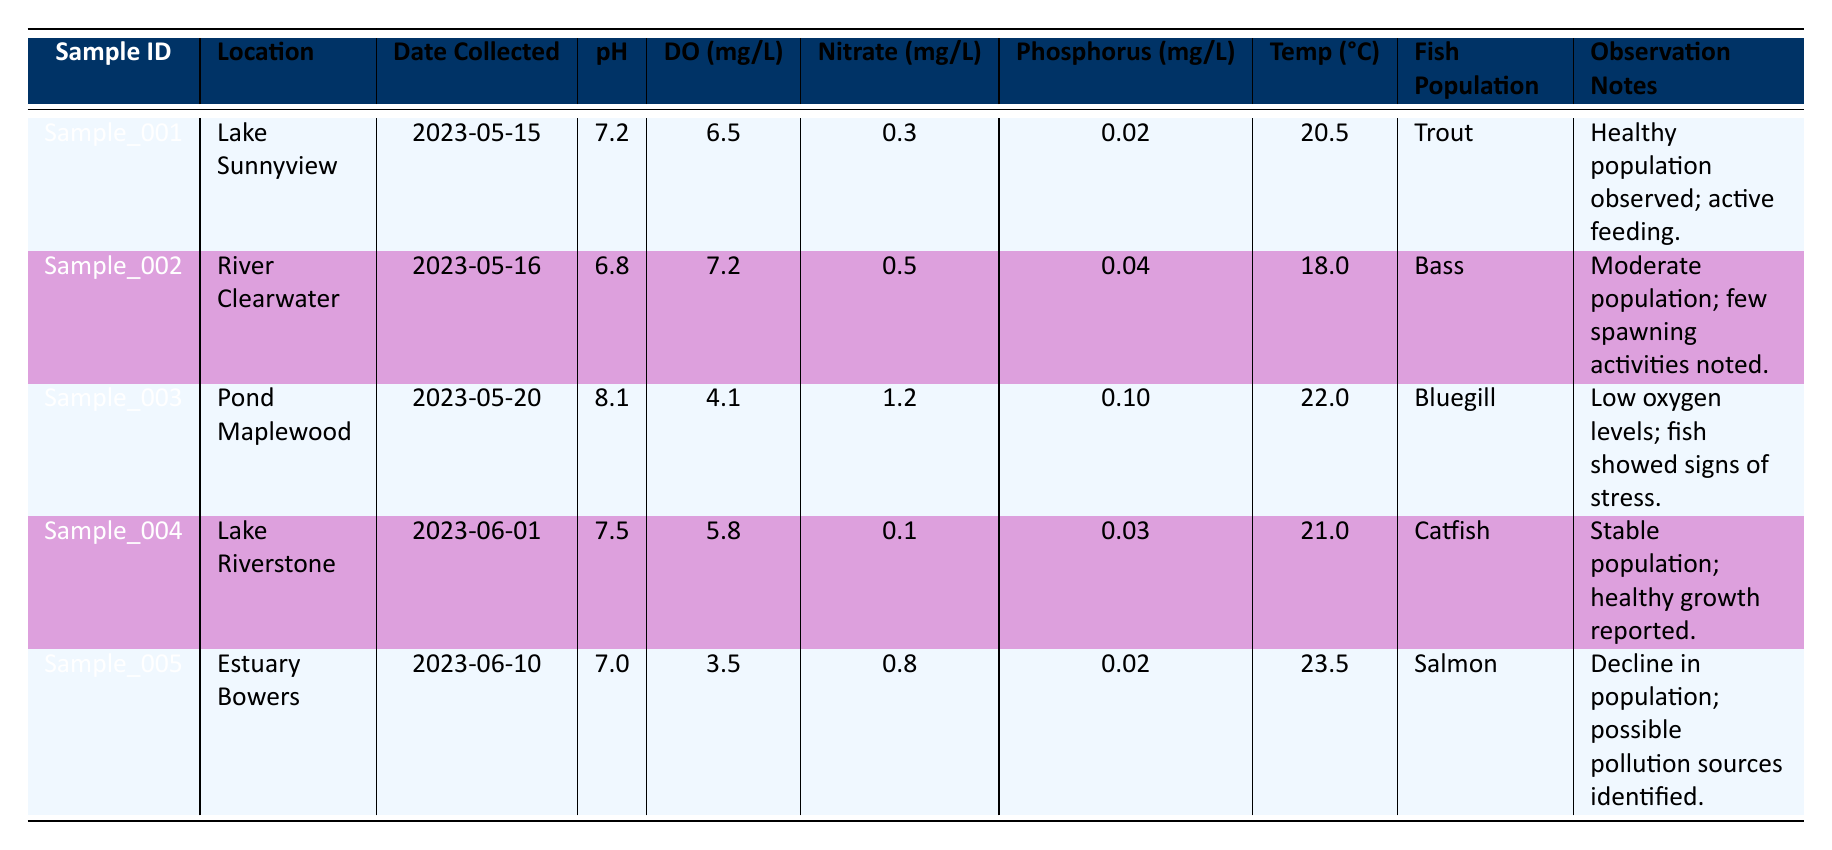What is the pH level of the water at Lake Sunnyview? The table shows a sample taken from Lake Sunnyview, which includes a pH value listed in the pH column. According to the row for Sample_001, the pH level is 7.2.
Answer: 7.2 Which fish population was observed in the River Clearwater? To determine the fish population in River Clearwater, look at the entry for Sample_002 where this location is mentioned. The fish population for this sample is recorded as Bass.
Answer: Bass What is the average temperature of the water samples collected? The temperatures from the table are: 20.5, 18.0, 22.0, 21.0, and 23.5 degrees Celsius. To find the average, we add these temperatures: 20.5 + 18.0 + 22.0 + 21.0 + 23.5 = 105.0. Then, we divide by the number of samples, which is 5: 105.0 / 5 = 21.0.
Answer: 21.0 Did the Bluegill fish population show any signs of stress? The table provides observation notes for Sample_003, where Bluegill was the fish population. The notes specifically mention that "fish showed signs of stress," confirming that they did exhibit distress.
Answer: Yes What can be inferred about the relationship between dissolved oxygen levels and fish population health from the samples? To analyze this, we need to compare the dissolved oxygen levels with population health noted for different fish species. For instance, Sample_003 (Bluegill) had a low dissolved oxygen of 4.1 mg/L and noted stress, while Sample_001 (Trout) had a healthy population with 6.5 mg/L. A clearer pattern emerges: higher dissolved oxygen levels seem to correlate with healthier populations, indicating the importance of oxygen for fish health.
Answer: Higher dissolved oxygen correlates with healthier fish populations 